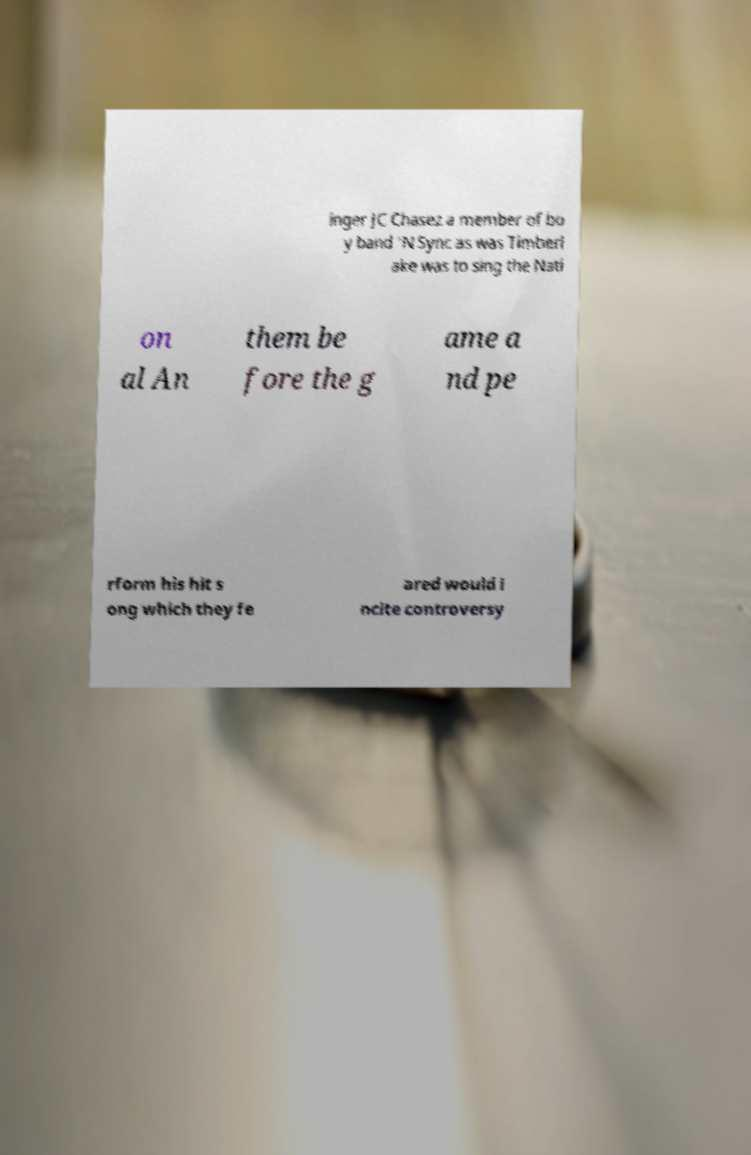I need the written content from this picture converted into text. Can you do that? inger JC Chasez a member of bo y band 'N Sync as was Timberl ake was to sing the Nati on al An them be fore the g ame a nd pe rform his hit s ong which they fe ared would i ncite controversy 